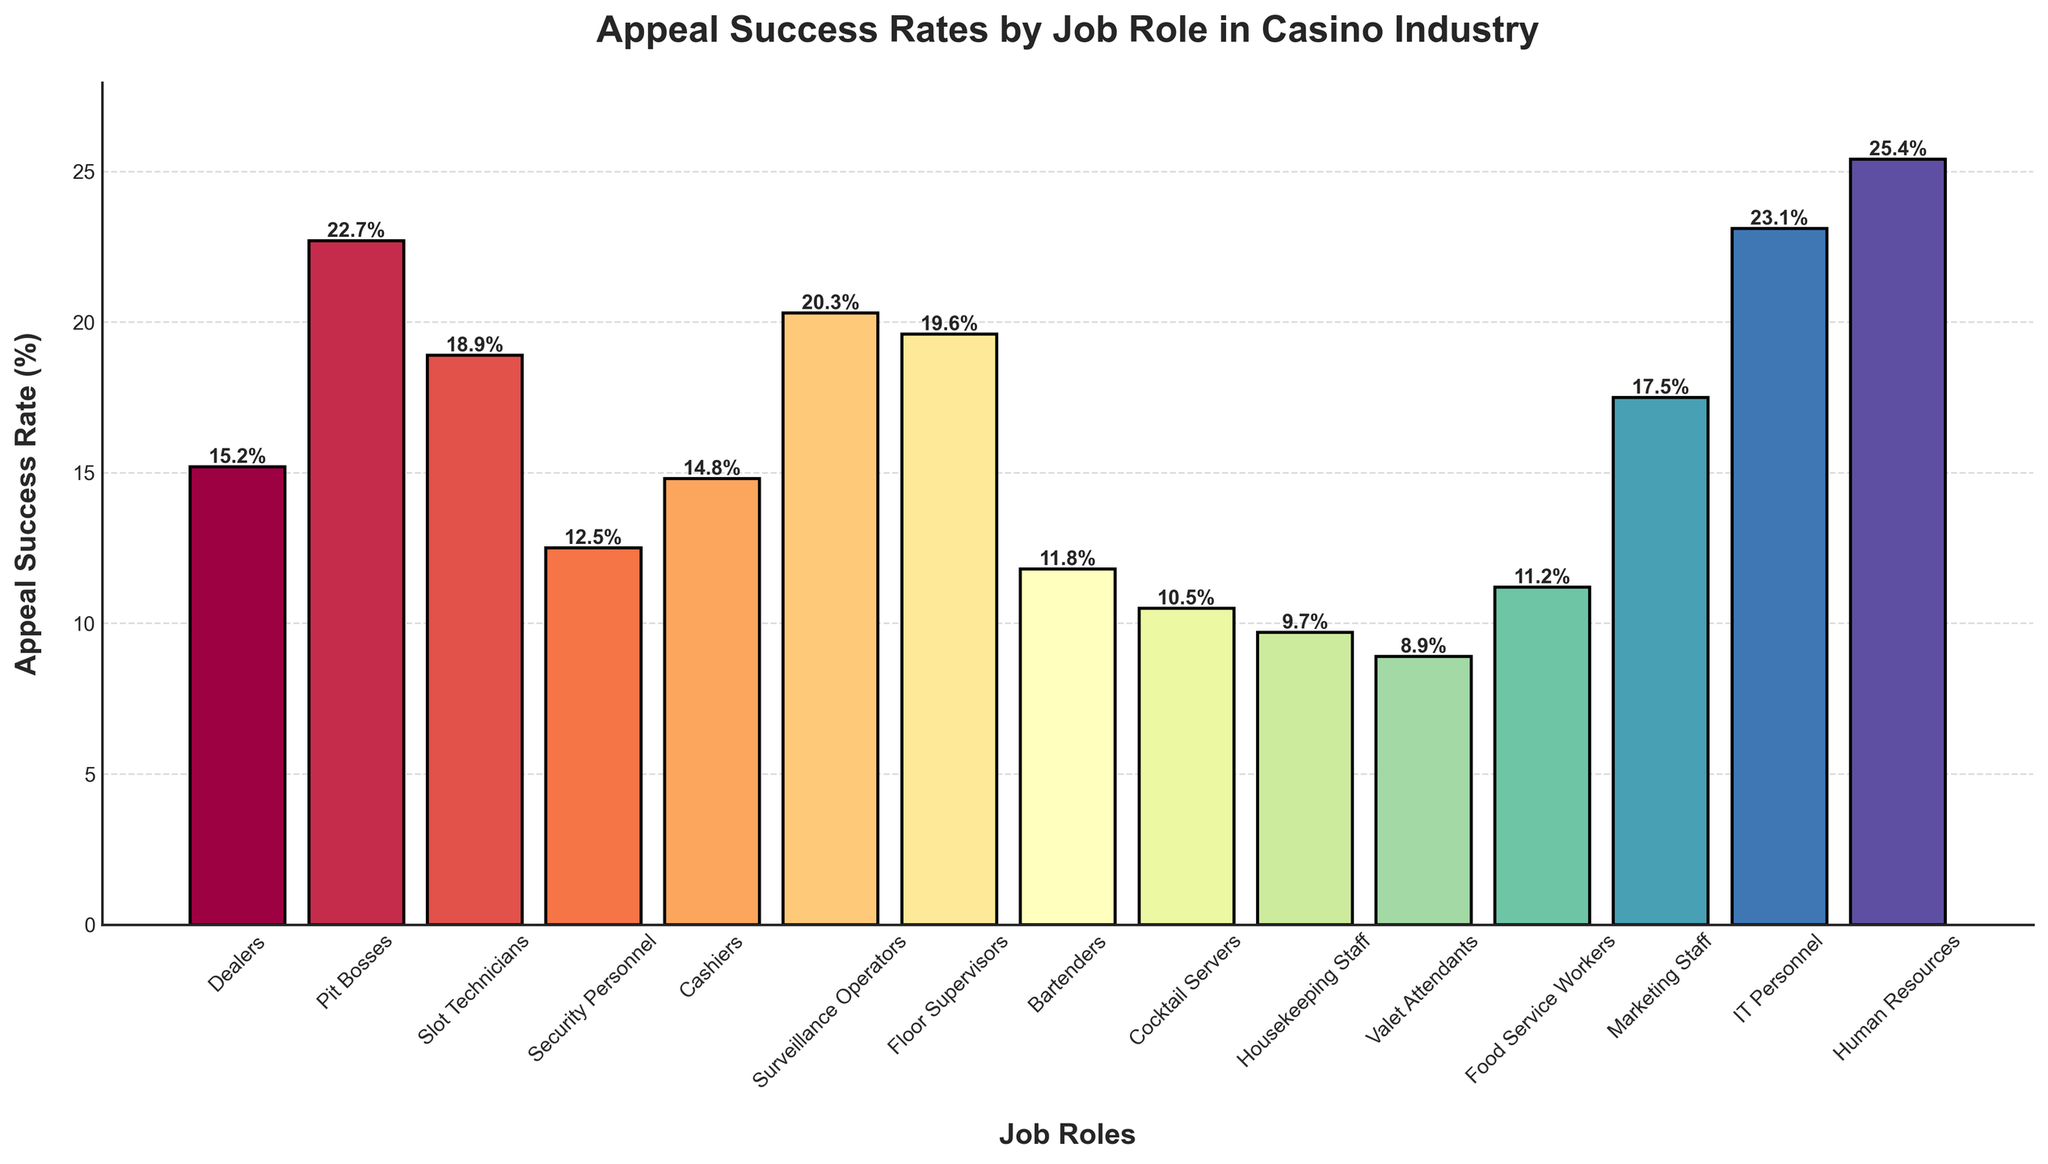Which job role has the highest appeal success rate? From the bar chart, look for the job role with the tallest bar among all the bars displayed. This will be the job role with the highest appeal success rate.
Answer: Human Resources Which job role has a lower appeal success rate, Security Personnel or Cashiers? Compare the heights of the bars representing Security Personnel and Cashiers. The bar with the lower height indicates the job with a lower appeal success rate.
Answer: Security Personnel What are the two job roles with the highest appeal success rates? Identify the two tallest bars in the bar chart, which represent the job roles with the highest appeal success rates.
Answer: Human Resources and IT Personnel What is the difference between the appeal success rate of Dealers and Bartenders? Locate the bars for Dealers and Bartenders and note their appeal success rates. Subtract the Bartenders' rate from the Dealers' rate to find the difference.
Answer: 3.4% Which job role has the lowest appeal success rate, and what is the value? Look for the shortest bar among all the bars displayed, which indicates the job role with the lowest appeal success rate. Also, check its exact value.
Answer: Valet Attendants, 8.9% What is the average appeal success rate of Dealers, Pit Bosses, and Slot Technicians? Note the appeal success rates of Dealers, Pit Bosses, and Slot Technicians. Add these rates together and divide by three to find the average.
Answer: 18.9333% What is the range of appeal success rates in the bar chart? Identify the largest and smallest appeal success rates in the chart. Subtract the smallest value from the largest value to find the range.
Answer: 16.5% Which job role has a higher appeal success rate, Surveillance Operators or Marketing Staff? Compare the heights of the bars representing Surveillance Operators and Marketing Staff. The bar with the higher height indicates the job with the higher appeal success rate.
Answer: Surveillance Operators What is the total appeal success rate of Job Roles that have a rate higher than 20%? Look at bars with success rates higher than 20%. Sum up their individual success rates. The job roles meeting this criterion are Pit Bosses (22.7%), IT Personnel (23.1%), Surveillance Operators (20.3%), and Human Resources (25.4%).
Answer: 91.5% What visual cue indicates that IT Personnel have one of the highest appeal success rates? The height of the bar for IT Personnel is one of the tallest in the chart, indicating a high appeal success rate.
Answer: The height of the bar 